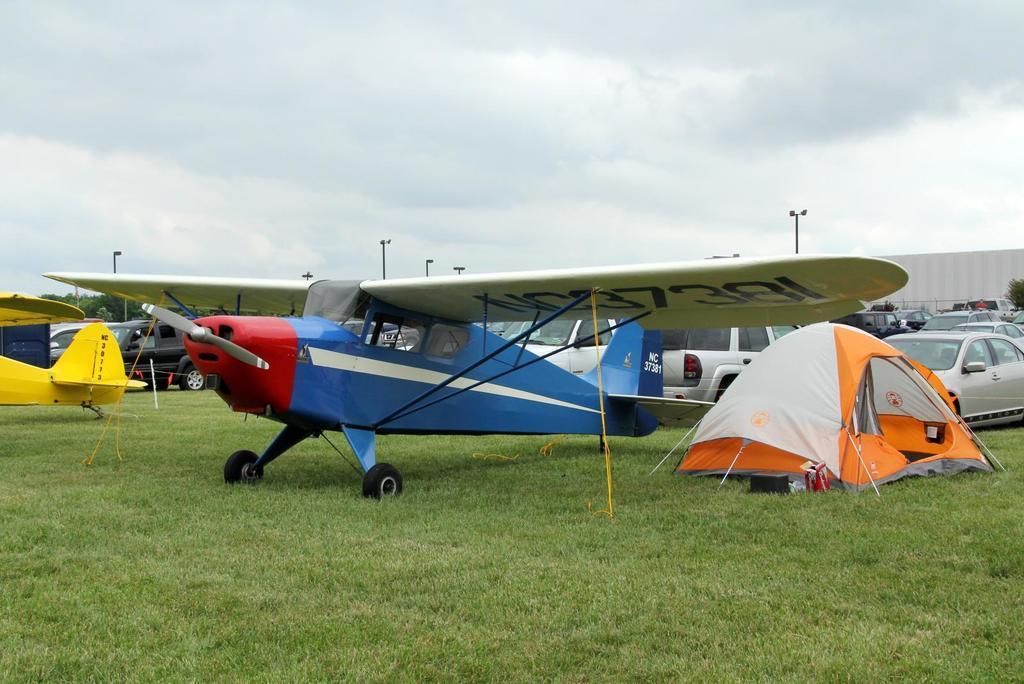Could you give a brief overview of what you see in this image? In the center of the image, we can see airplanes, tents, vehicles, boards, poles and there are trees. At the bottom, there is ground and at the top, there is sky. 